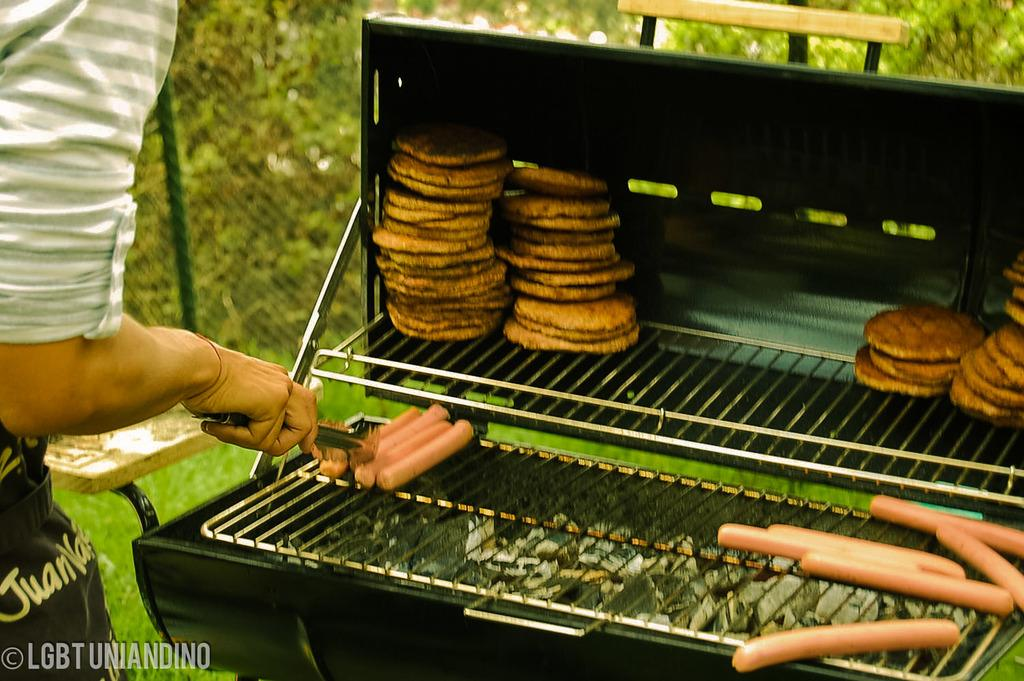<image>
Present a compact description of the photo's key features. A person arranging hotdogs on a charcoal grill. 